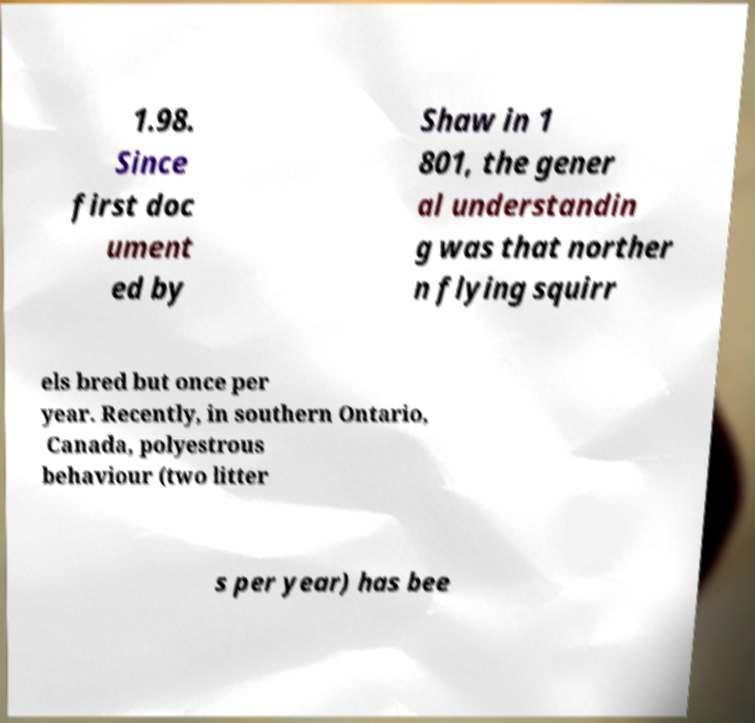Can you read and provide the text displayed in the image?This photo seems to have some interesting text. Can you extract and type it out for me? 1.98. Since first doc ument ed by Shaw in 1 801, the gener al understandin g was that norther n flying squirr els bred but once per year. Recently, in southern Ontario, Canada, polyestrous behaviour (two litter s per year) has bee 